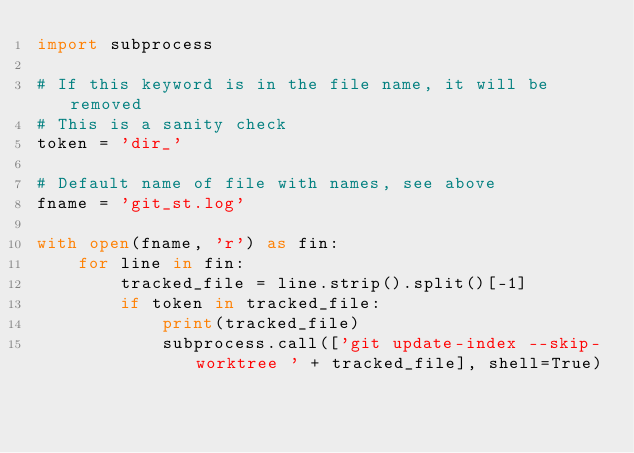<code> <loc_0><loc_0><loc_500><loc_500><_Python_>import subprocess

# If this keyword is in the file name, it will be removed
# This is a sanity check
token = 'dir_'

# Default name of file with names, see above
fname = 'git_st.log'

with open(fname, 'r') as fin:
	for line in fin:
		tracked_file = line.strip().split()[-1]
		if token in tracked_file:
			print(tracked_file)
			subprocess.call(['git update-index --skip-worktree ' + tracked_file], shell=True)	
</code> 